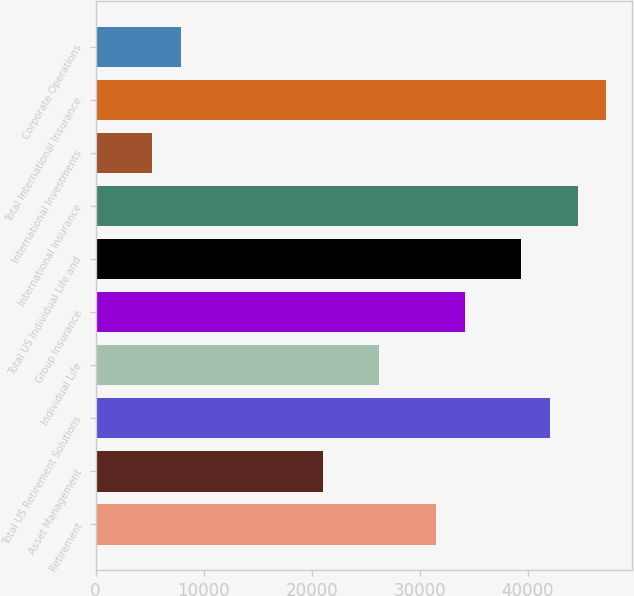Convert chart. <chart><loc_0><loc_0><loc_500><loc_500><bar_chart><fcel>Retirement<fcel>Asset Management<fcel>Total US Retirement Solutions<fcel>Individual Life<fcel>Group Insurance<fcel>Total US Individual Life and<fcel>International Insurance<fcel>International Investments<fcel>Total International Insurance<fcel>Corporate Operations<nl><fcel>31522<fcel>21016<fcel>42028<fcel>26269<fcel>34148.5<fcel>39401.5<fcel>44654.5<fcel>5257.02<fcel>47281<fcel>7883.52<nl></chart> 